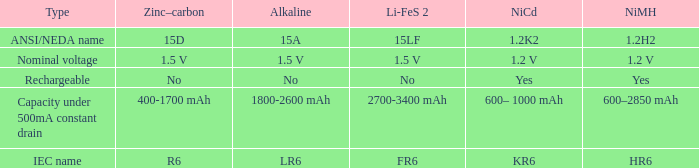What is Li-FeS 2, when Type is Nominal Voltage? 1.5 V. 